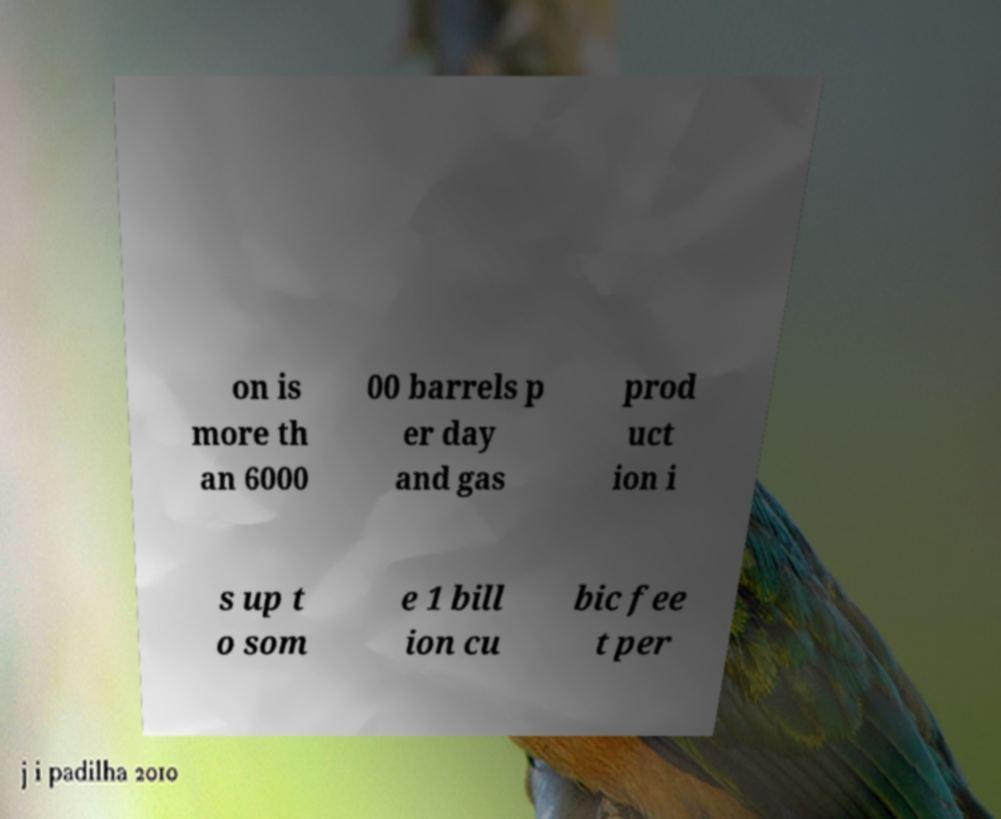Please read and relay the text visible in this image. What does it say? on is more th an 6000 00 barrels p er day and gas prod uct ion i s up t o som e 1 bill ion cu bic fee t per 